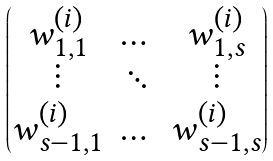Convert formula to latex. <formula><loc_0><loc_0><loc_500><loc_500>\begin{pmatrix} w _ { 1 , 1 } ^ { ( i ) } & \dots & w _ { 1 , s } ^ { ( i ) } \\ \vdots & \ddots & \vdots \\ w _ { s - 1 , 1 } ^ { ( i ) } & \dots & w _ { s - 1 , s } ^ { ( i ) } \end{pmatrix}</formula> 